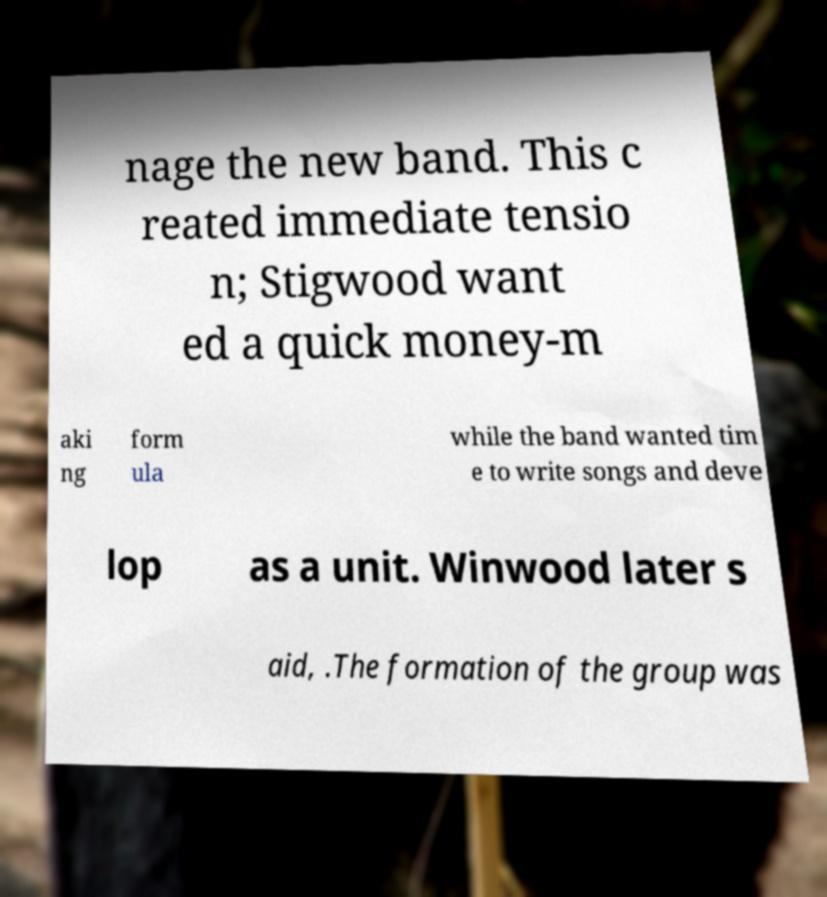Please identify and transcribe the text found in this image. nage the new band. This c reated immediate tensio n; Stigwood want ed a quick money-m aki ng form ula while the band wanted tim e to write songs and deve lop as a unit. Winwood later s aid, .The formation of the group was 